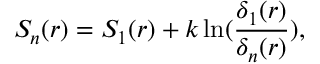Convert formula to latex. <formula><loc_0><loc_0><loc_500><loc_500>S _ { n } ( r ) = S _ { 1 } ( r ) + k \ln ( { \frac { \delta _ { 1 } ( r ) } { \delta _ { n } ( r ) } } ) ,</formula> 